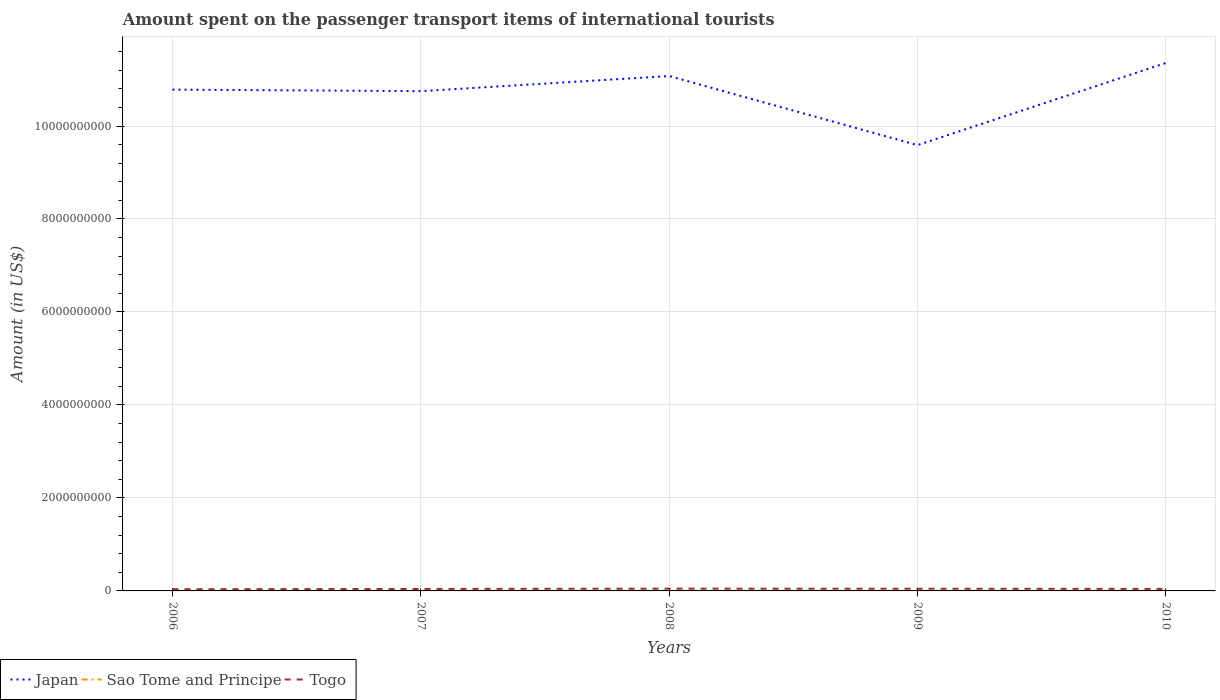How many different coloured lines are there?
Provide a short and direct response. 3. Does the line corresponding to Japan intersect with the line corresponding to Togo?
Provide a short and direct response. No. Across all years, what is the maximum amount spent on the passenger transport items of international tourists in Japan?
Offer a terse response. 9.59e+09. In which year was the amount spent on the passenger transport items of international tourists in Sao Tome and Principe maximum?
Offer a terse response. 2008. What is the total amount spent on the passenger transport items of international tourists in Japan in the graph?
Offer a terse response. -3.25e+08. What is the difference between the highest and the second highest amount spent on the passenger transport items of international tourists in Sao Tome and Principe?
Your response must be concise. 6.00e+05. Are the values on the major ticks of Y-axis written in scientific E-notation?
Provide a succinct answer. No. Does the graph contain any zero values?
Offer a very short reply. No. How many legend labels are there?
Make the answer very short. 3. How are the legend labels stacked?
Your response must be concise. Horizontal. What is the title of the graph?
Make the answer very short. Amount spent on the passenger transport items of international tourists. What is the label or title of the X-axis?
Ensure brevity in your answer.  Years. What is the Amount (in US$) in Japan in 2006?
Your response must be concise. 1.08e+1. What is the Amount (in US$) of Sao Tome and Principe in 2006?
Keep it short and to the point. 9.00e+05. What is the Amount (in US$) in Togo in 2006?
Offer a very short reply. 3.70e+07. What is the Amount (in US$) of Japan in 2007?
Ensure brevity in your answer.  1.08e+1. What is the Amount (in US$) of Togo in 2007?
Make the answer very short. 4.20e+07. What is the Amount (in US$) of Japan in 2008?
Your answer should be very brief. 1.11e+1. What is the Amount (in US$) in Sao Tome and Principe in 2008?
Provide a short and direct response. 3.00e+05. What is the Amount (in US$) in Togo in 2008?
Your answer should be very brief. 4.90e+07. What is the Amount (in US$) in Japan in 2009?
Your response must be concise. 9.59e+09. What is the Amount (in US$) in Sao Tome and Principe in 2009?
Give a very brief answer. 4.00e+05. What is the Amount (in US$) of Togo in 2009?
Your answer should be compact. 4.70e+07. What is the Amount (in US$) of Japan in 2010?
Offer a very short reply. 1.14e+1. What is the Amount (in US$) of Togo in 2010?
Provide a short and direct response. 4.30e+07. Across all years, what is the maximum Amount (in US$) of Japan?
Ensure brevity in your answer.  1.14e+1. Across all years, what is the maximum Amount (in US$) of Togo?
Your response must be concise. 4.90e+07. Across all years, what is the minimum Amount (in US$) in Japan?
Provide a short and direct response. 9.59e+09. Across all years, what is the minimum Amount (in US$) in Sao Tome and Principe?
Your response must be concise. 3.00e+05. Across all years, what is the minimum Amount (in US$) in Togo?
Offer a very short reply. 3.70e+07. What is the total Amount (in US$) of Japan in the graph?
Your answer should be compact. 5.36e+1. What is the total Amount (in US$) in Sao Tome and Principe in the graph?
Your answer should be compact. 2.70e+06. What is the total Amount (in US$) in Togo in the graph?
Ensure brevity in your answer.  2.18e+08. What is the difference between the Amount (in US$) of Japan in 2006 and that in 2007?
Offer a very short reply. 3.30e+07. What is the difference between the Amount (in US$) in Sao Tome and Principe in 2006 and that in 2007?
Your answer should be very brief. 3.00e+05. What is the difference between the Amount (in US$) of Togo in 2006 and that in 2007?
Your answer should be compact. -5.00e+06. What is the difference between the Amount (in US$) in Japan in 2006 and that in 2008?
Your answer should be compact. -2.92e+08. What is the difference between the Amount (in US$) of Togo in 2006 and that in 2008?
Make the answer very short. -1.20e+07. What is the difference between the Amount (in US$) of Japan in 2006 and that in 2009?
Your answer should be very brief. 1.19e+09. What is the difference between the Amount (in US$) of Sao Tome and Principe in 2006 and that in 2009?
Your answer should be compact. 5.00e+05. What is the difference between the Amount (in US$) of Togo in 2006 and that in 2009?
Give a very brief answer. -1.00e+07. What is the difference between the Amount (in US$) in Japan in 2006 and that in 2010?
Your answer should be very brief. -5.73e+08. What is the difference between the Amount (in US$) in Sao Tome and Principe in 2006 and that in 2010?
Keep it short and to the point. 4.00e+05. What is the difference between the Amount (in US$) of Togo in 2006 and that in 2010?
Ensure brevity in your answer.  -6.00e+06. What is the difference between the Amount (in US$) of Japan in 2007 and that in 2008?
Your response must be concise. -3.25e+08. What is the difference between the Amount (in US$) of Sao Tome and Principe in 2007 and that in 2008?
Your answer should be very brief. 3.00e+05. What is the difference between the Amount (in US$) in Togo in 2007 and that in 2008?
Offer a terse response. -7.00e+06. What is the difference between the Amount (in US$) of Japan in 2007 and that in 2009?
Keep it short and to the point. 1.16e+09. What is the difference between the Amount (in US$) in Sao Tome and Principe in 2007 and that in 2009?
Keep it short and to the point. 2.00e+05. What is the difference between the Amount (in US$) of Togo in 2007 and that in 2009?
Your answer should be very brief. -5.00e+06. What is the difference between the Amount (in US$) in Japan in 2007 and that in 2010?
Give a very brief answer. -6.06e+08. What is the difference between the Amount (in US$) of Sao Tome and Principe in 2007 and that in 2010?
Your answer should be compact. 1.00e+05. What is the difference between the Amount (in US$) of Japan in 2008 and that in 2009?
Offer a very short reply. 1.49e+09. What is the difference between the Amount (in US$) of Sao Tome and Principe in 2008 and that in 2009?
Ensure brevity in your answer.  -1.00e+05. What is the difference between the Amount (in US$) of Togo in 2008 and that in 2009?
Your response must be concise. 2.00e+06. What is the difference between the Amount (in US$) of Japan in 2008 and that in 2010?
Offer a very short reply. -2.81e+08. What is the difference between the Amount (in US$) of Sao Tome and Principe in 2008 and that in 2010?
Provide a short and direct response. -2.00e+05. What is the difference between the Amount (in US$) in Japan in 2009 and that in 2010?
Keep it short and to the point. -1.77e+09. What is the difference between the Amount (in US$) of Sao Tome and Principe in 2009 and that in 2010?
Offer a very short reply. -1.00e+05. What is the difference between the Amount (in US$) in Japan in 2006 and the Amount (in US$) in Sao Tome and Principe in 2007?
Your answer should be compact. 1.08e+1. What is the difference between the Amount (in US$) in Japan in 2006 and the Amount (in US$) in Togo in 2007?
Your response must be concise. 1.07e+1. What is the difference between the Amount (in US$) of Sao Tome and Principe in 2006 and the Amount (in US$) of Togo in 2007?
Make the answer very short. -4.11e+07. What is the difference between the Amount (in US$) in Japan in 2006 and the Amount (in US$) in Sao Tome and Principe in 2008?
Offer a very short reply. 1.08e+1. What is the difference between the Amount (in US$) of Japan in 2006 and the Amount (in US$) of Togo in 2008?
Make the answer very short. 1.07e+1. What is the difference between the Amount (in US$) in Sao Tome and Principe in 2006 and the Amount (in US$) in Togo in 2008?
Your response must be concise. -4.81e+07. What is the difference between the Amount (in US$) of Japan in 2006 and the Amount (in US$) of Sao Tome and Principe in 2009?
Your answer should be very brief. 1.08e+1. What is the difference between the Amount (in US$) in Japan in 2006 and the Amount (in US$) in Togo in 2009?
Ensure brevity in your answer.  1.07e+1. What is the difference between the Amount (in US$) of Sao Tome and Principe in 2006 and the Amount (in US$) of Togo in 2009?
Provide a succinct answer. -4.61e+07. What is the difference between the Amount (in US$) of Japan in 2006 and the Amount (in US$) of Sao Tome and Principe in 2010?
Your answer should be compact. 1.08e+1. What is the difference between the Amount (in US$) in Japan in 2006 and the Amount (in US$) in Togo in 2010?
Provide a short and direct response. 1.07e+1. What is the difference between the Amount (in US$) of Sao Tome and Principe in 2006 and the Amount (in US$) of Togo in 2010?
Give a very brief answer. -4.21e+07. What is the difference between the Amount (in US$) in Japan in 2007 and the Amount (in US$) in Sao Tome and Principe in 2008?
Your answer should be compact. 1.07e+1. What is the difference between the Amount (in US$) in Japan in 2007 and the Amount (in US$) in Togo in 2008?
Make the answer very short. 1.07e+1. What is the difference between the Amount (in US$) in Sao Tome and Principe in 2007 and the Amount (in US$) in Togo in 2008?
Provide a short and direct response. -4.84e+07. What is the difference between the Amount (in US$) in Japan in 2007 and the Amount (in US$) in Sao Tome and Principe in 2009?
Make the answer very short. 1.07e+1. What is the difference between the Amount (in US$) of Japan in 2007 and the Amount (in US$) of Togo in 2009?
Offer a terse response. 1.07e+1. What is the difference between the Amount (in US$) in Sao Tome and Principe in 2007 and the Amount (in US$) in Togo in 2009?
Provide a short and direct response. -4.64e+07. What is the difference between the Amount (in US$) in Japan in 2007 and the Amount (in US$) in Sao Tome and Principe in 2010?
Your response must be concise. 1.07e+1. What is the difference between the Amount (in US$) of Japan in 2007 and the Amount (in US$) of Togo in 2010?
Ensure brevity in your answer.  1.07e+1. What is the difference between the Amount (in US$) of Sao Tome and Principe in 2007 and the Amount (in US$) of Togo in 2010?
Provide a short and direct response. -4.24e+07. What is the difference between the Amount (in US$) in Japan in 2008 and the Amount (in US$) in Sao Tome and Principe in 2009?
Give a very brief answer. 1.11e+1. What is the difference between the Amount (in US$) of Japan in 2008 and the Amount (in US$) of Togo in 2009?
Provide a succinct answer. 1.10e+1. What is the difference between the Amount (in US$) in Sao Tome and Principe in 2008 and the Amount (in US$) in Togo in 2009?
Offer a terse response. -4.67e+07. What is the difference between the Amount (in US$) in Japan in 2008 and the Amount (in US$) in Sao Tome and Principe in 2010?
Offer a very short reply. 1.11e+1. What is the difference between the Amount (in US$) of Japan in 2008 and the Amount (in US$) of Togo in 2010?
Provide a succinct answer. 1.10e+1. What is the difference between the Amount (in US$) of Sao Tome and Principe in 2008 and the Amount (in US$) of Togo in 2010?
Provide a short and direct response. -4.27e+07. What is the difference between the Amount (in US$) in Japan in 2009 and the Amount (in US$) in Sao Tome and Principe in 2010?
Give a very brief answer. 9.59e+09. What is the difference between the Amount (in US$) of Japan in 2009 and the Amount (in US$) of Togo in 2010?
Your answer should be very brief. 9.55e+09. What is the difference between the Amount (in US$) of Sao Tome and Principe in 2009 and the Amount (in US$) of Togo in 2010?
Keep it short and to the point. -4.26e+07. What is the average Amount (in US$) in Japan per year?
Provide a succinct answer. 1.07e+1. What is the average Amount (in US$) of Sao Tome and Principe per year?
Your answer should be compact. 5.40e+05. What is the average Amount (in US$) of Togo per year?
Give a very brief answer. 4.36e+07. In the year 2006, what is the difference between the Amount (in US$) of Japan and Amount (in US$) of Sao Tome and Principe?
Ensure brevity in your answer.  1.08e+1. In the year 2006, what is the difference between the Amount (in US$) in Japan and Amount (in US$) in Togo?
Your answer should be compact. 1.07e+1. In the year 2006, what is the difference between the Amount (in US$) of Sao Tome and Principe and Amount (in US$) of Togo?
Offer a very short reply. -3.61e+07. In the year 2007, what is the difference between the Amount (in US$) in Japan and Amount (in US$) in Sao Tome and Principe?
Your answer should be compact. 1.07e+1. In the year 2007, what is the difference between the Amount (in US$) of Japan and Amount (in US$) of Togo?
Give a very brief answer. 1.07e+1. In the year 2007, what is the difference between the Amount (in US$) in Sao Tome and Principe and Amount (in US$) in Togo?
Keep it short and to the point. -4.14e+07. In the year 2008, what is the difference between the Amount (in US$) in Japan and Amount (in US$) in Sao Tome and Principe?
Ensure brevity in your answer.  1.11e+1. In the year 2008, what is the difference between the Amount (in US$) in Japan and Amount (in US$) in Togo?
Your answer should be compact. 1.10e+1. In the year 2008, what is the difference between the Amount (in US$) in Sao Tome and Principe and Amount (in US$) in Togo?
Provide a succinct answer. -4.87e+07. In the year 2009, what is the difference between the Amount (in US$) in Japan and Amount (in US$) in Sao Tome and Principe?
Your answer should be compact. 9.59e+09. In the year 2009, what is the difference between the Amount (in US$) of Japan and Amount (in US$) of Togo?
Your answer should be compact. 9.54e+09. In the year 2009, what is the difference between the Amount (in US$) of Sao Tome and Principe and Amount (in US$) of Togo?
Offer a very short reply. -4.66e+07. In the year 2010, what is the difference between the Amount (in US$) in Japan and Amount (in US$) in Sao Tome and Principe?
Give a very brief answer. 1.14e+1. In the year 2010, what is the difference between the Amount (in US$) in Japan and Amount (in US$) in Togo?
Your response must be concise. 1.13e+1. In the year 2010, what is the difference between the Amount (in US$) of Sao Tome and Principe and Amount (in US$) of Togo?
Your answer should be compact. -4.25e+07. What is the ratio of the Amount (in US$) in Togo in 2006 to that in 2007?
Make the answer very short. 0.88. What is the ratio of the Amount (in US$) in Japan in 2006 to that in 2008?
Give a very brief answer. 0.97. What is the ratio of the Amount (in US$) in Sao Tome and Principe in 2006 to that in 2008?
Your answer should be very brief. 3. What is the ratio of the Amount (in US$) in Togo in 2006 to that in 2008?
Your answer should be compact. 0.76. What is the ratio of the Amount (in US$) in Japan in 2006 to that in 2009?
Keep it short and to the point. 1.12. What is the ratio of the Amount (in US$) in Sao Tome and Principe in 2006 to that in 2009?
Your answer should be compact. 2.25. What is the ratio of the Amount (in US$) of Togo in 2006 to that in 2009?
Your response must be concise. 0.79. What is the ratio of the Amount (in US$) in Japan in 2006 to that in 2010?
Provide a succinct answer. 0.95. What is the ratio of the Amount (in US$) of Togo in 2006 to that in 2010?
Make the answer very short. 0.86. What is the ratio of the Amount (in US$) in Japan in 2007 to that in 2008?
Your answer should be very brief. 0.97. What is the ratio of the Amount (in US$) in Japan in 2007 to that in 2009?
Your response must be concise. 1.12. What is the ratio of the Amount (in US$) of Sao Tome and Principe in 2007 to that in 2009?
Offer a very short reply. 1.5. What is the ratio of the Amount (in US$) of Togo in 2007 to that in 2009?
Ensure brevity in your answer.  0.89. What is the ratio of the Amount (in US$) of Japan in 2007 to that in 2010?
Make the answer very short. 0.95. What is the ratio of the Amount (in US$) in Sao Tome and Principe in 2007 to that in 2010?
Your response must be concise. 1.2. What is the ratio of the Amount (in US$) of Togo in 2007 to that in 2010?
Keep it short and to the point. 0.98. What is the ratio of the Amount (in US$) of Japan in 2008 to that in 2009?
Your answer should be compact. 1.16. What is the ratio of the Amount (in US$) of Sao Tome and Principe in 2008 to that in 2009?
Provide a succinct answer. 0.75. What is the ratio of the Amount (in US$) in Togo in 2008 to that in 2009?
Offer a terse response. 1.04. What is the ratio of the Amount (in US$) in Japan in 2008 to that in 2010?
Provide a short and direct response. 0.98. What is the ratio of the Amount (in US$) in Sao Tome and Principe in 2008 to that in 2010?
Provide a short and direct response. 0.6. What is the ratio of the Amount (in US$) of Togo in 2008 to that in 2010?
Provide a succinct answer. 1.14. What is the ratio of the Amount (in US$) of Japan in 2009 to that in 2010?
Keep it short and to the point. 0.84. What is the ratio of the Amount (in US$) in Togo in 2009 to that in 2010?
Provide a succinct answer. 1.09. What is the difference between the highest and the second highest Amount (in US$) of Japan?
Give a very brief answer. 2.81e+08. What is the difference between the highest and the second highest Amount (in US$) in Sao Tome and Principe?
Your answer should be compact. 3.00e+05. What is the difference between the highest and the lowest Amount (in US$) in Japan?
Make the answer very short. 1.77e+09. 